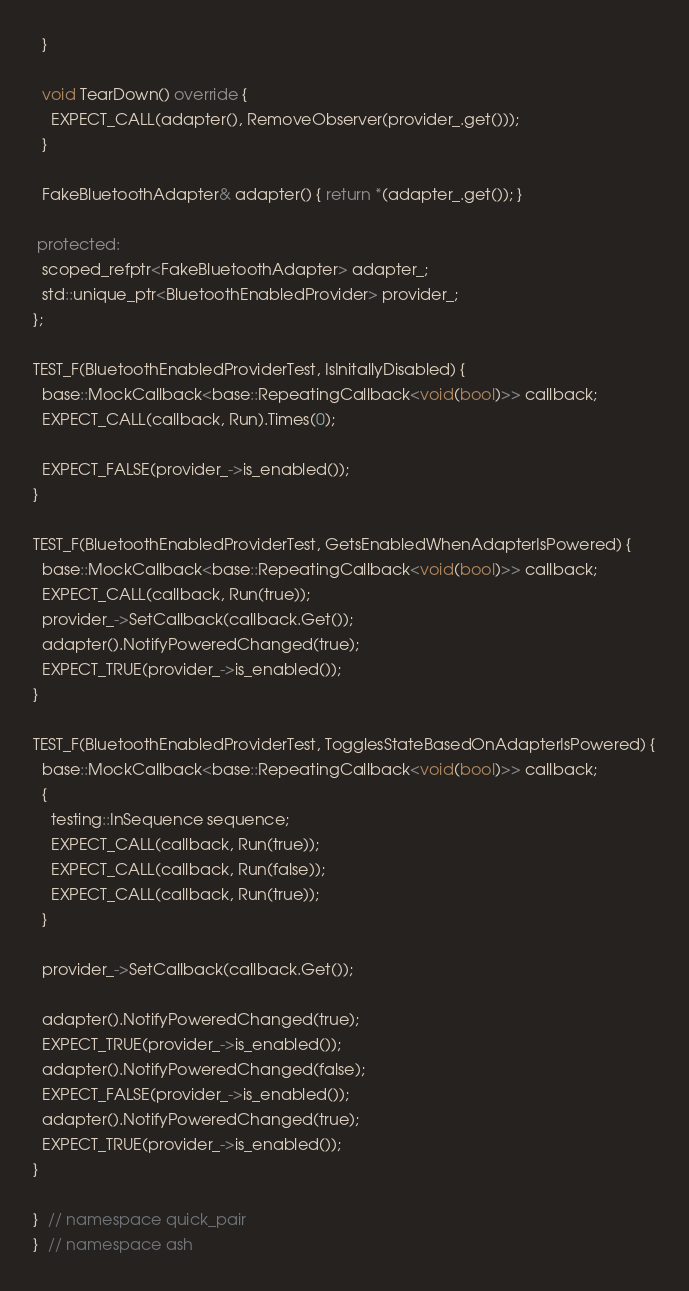<code> <loc_0><loc_0><loc_500><loc_500><_C++_>  }

  void TearDown() override {
    EXPECT_CALL(adapter(), RemoveObserver(provider_.get()));
  }

  FakeBluetoothAdapter& adapter() { return *(adapter_.get()); }

 protected:
  scoped_refptr<FakeBluetoothAdapter> adapter_;
  std::unique_ptr<BluetoothEnabledProvider> provider_;
};

TEST_F(BluetoothEnabledProviderTest, IsInitallyDisabled) {
  base::MockCallback<base::RepeatingCallback<void(bool)>> callback;
  EXPECT_CALL(callback, Run).Times(0);

  EXPECT_FALSE(provider_->is_enabled());
}

TEST_F(BluetoothEnabledProviderTest, GetsEnabledWhenAdapterIsPowered) {
  base::MockCallback<base::RepeatingCallback<void(bool)>> callback;
  EXPECT_CALL(callback, Run(true));
  provider_->SetCallback(callback.Get());
  adapter().NotifyPoweredChanged(true);
  EXPECT_TRUE(provider_->is_enabled());
}

TEST_F(BluetoothEnabledProviderTest, TogglesStateBasedOnAdapterIsPowered) {
  base::MockCallback<base::RepeatingCallback<void(bool)>> callback;
  {
    testing::InSequence sequence;
    EXPECT_CALL(callback, Run(true));
    EXPECT_CALL(callback, Run(false));
    EXPECT_CALL(callback, Run(true));
  }

  provider_->SetCallback(callback.Get());

  adapter().NotifyPoweredChanged(true);
  EXPECT_TRUE(provider_->is_enabled());
  adapter().NotifyPoweredChanged(false);
  EXPECT_FALSE(provider_->is_enabled());
  adapter().NotifyPoweredChanged(true);
  EXPECT_TRUE(provider_->is_enabled());
}

}  // namespace quick_pair
}  // namespace ash
</code> 